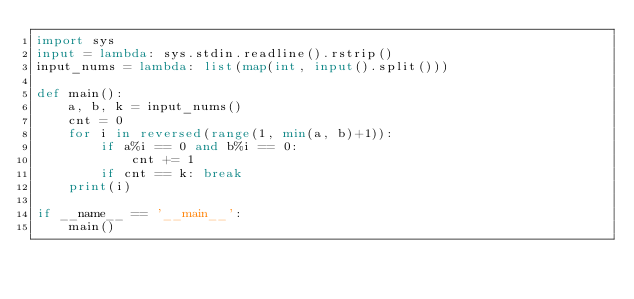<code> <loc_0><loc_0><loc_500><loc_500><_Python_>import sys
input = lambda: sys.stdin.readline().rstrip()
input_nums = lambda: list(map(int, input().split()))

def main():
    a, b, k = input_nums()
    cnt = 0
    for i in reversed(range(1, min(a, b)+1)):
        if a%i == 0 and b%i == 0:
            cnt += 1
        if cnt == k: break
    print(i)

if __name__ == '__main__':
    main()
</code> 